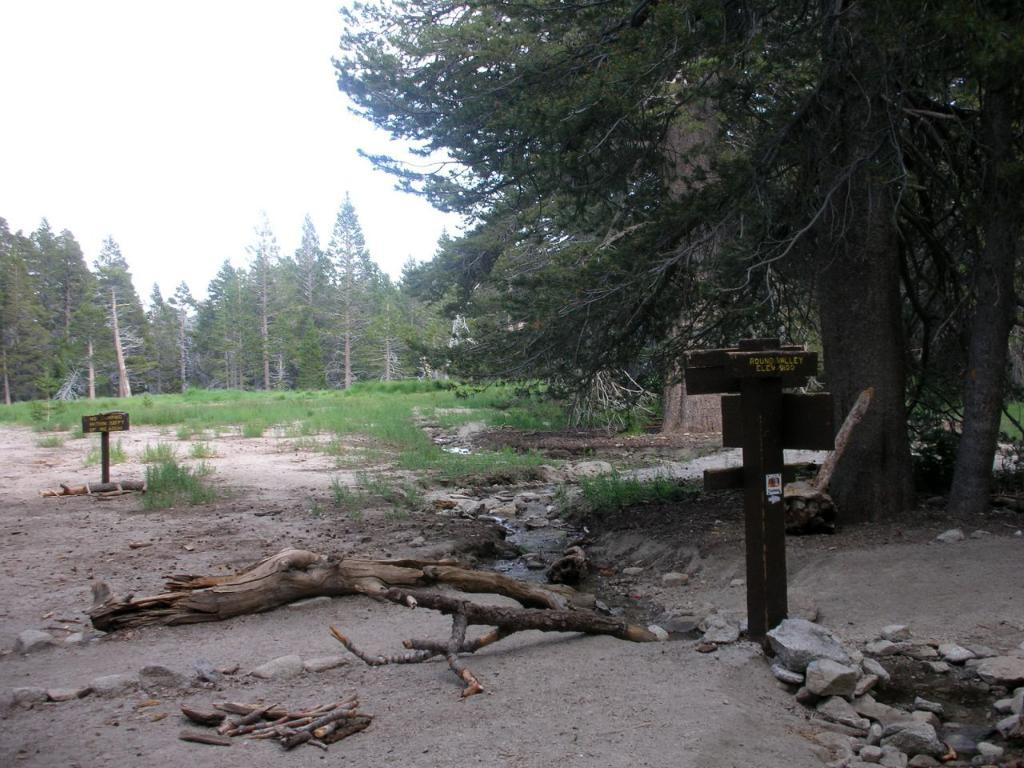What type of materials can be seen in the image? Wooden logs, sticks, boards, and stones are visible in the image. What type of vegetation is in the background of the image? There are trees in the background of the image. What part of the natural environment is visible in the image? The sky is visible in the background of the image. What type of silk is being used to tie the wooden logs together in the image? There is no silk present in the image; the wooden logs are not tied together. How does the beginner learn to use the sticks in the image? There is no indication in the image that a beginner is learning to use the sticks, nor is there any context provided for such an activity. 